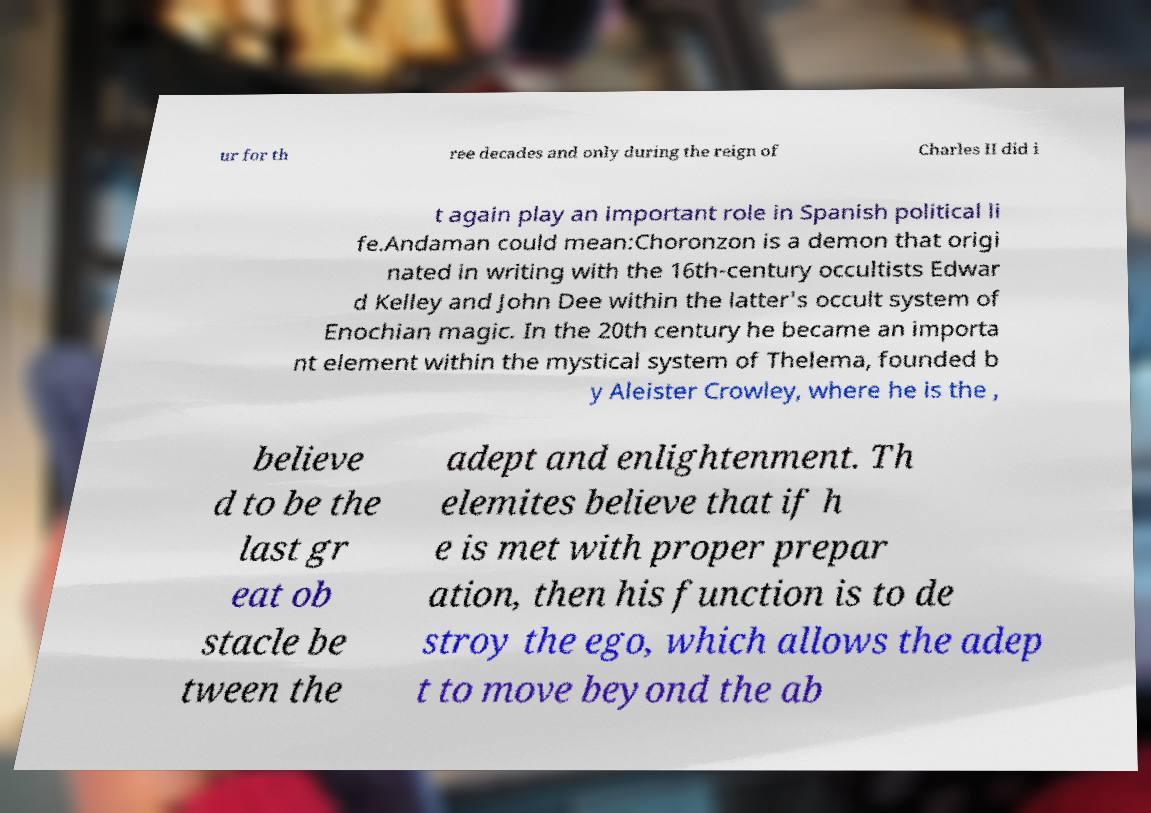What messages or text are displayed in this image? I need them in a readable, typed format. ur for th ree decades and only during the reign of Charles II did i t again play an important role in Spanish political li fe.Andaman could mean:Choronzon is a demon that origi nated in writing with the 16th-century occultists Edwar d Kelley and John Dee within the latter's occult system of Enochian magic. In the 20th century he became an importa nt element within the mystical system of Thelema, founded b y Aleister Crowley, where he is the , believe d to be the last gr eat ob stacle be tween the adept and enlightenment. Th elemites believe that if h e is met with proper prepar ation, then his function is to de stroy the ego, which allows the adep t to move beyond the ab 